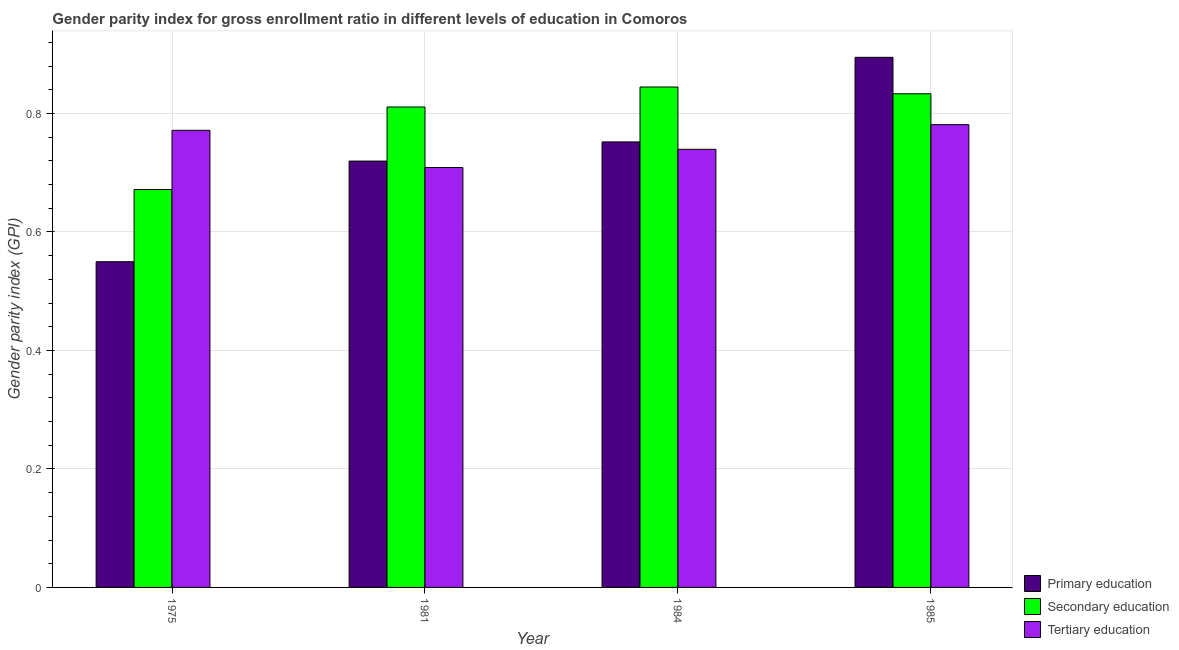How many different coloured bars are there?
Provide a succinct answer. 3. Are the number of bars per tick equal to the number of legend labels?
Your response must be concise. Yes. How many bars are there on the 2nd tick from the left?
Offer a very short reply. 3. What is the label of the 3rd group of bars from the left?
Offer a terse response. 1984. What is the gender parity index in tertiary education in 1985?
Keep it short and to the point. 0.78. Across all years, what is the maximum gender parity index in secondary education?
Offer a very short reply. 0.84. Across all years, what is the minimum gender parity index in primary education?
Provide a succinct answer. 0.55. What is the total gender parity index in tertiary education in the graph?
Your answer should be compact. 3. What is the difference between the gender parity index in secondary education in 1984 and that in 1985?
Your response must be concise. 0.01. What is the difference between the gender parity index in primary education in 1975 and the gender parity index in secondary education in 1981?
Your answer should be very brief. -0.17. What is the average gender parity index in secondary education per year?
Offer a very short reply. 0.79. In how many years, is the gender parity index in tertiary education greater than 0.4?
Your answer should be compact. 4. What is the ratio of the gender parity index in secondary education in 1975 to that in 1985?
Keep it short and to the point. 0.81. Is the gender parity index in tertiary education in 1981 less than that in 1984?
Offer a very short reply. Yes. Is the difference between the gender parity index in primary education in 1981 and 1984 greater than the difference between the gender parity index in secondary education in 1981 and 1984?
Your answer should be very brief. No. What is the difference between the highest and the second highest gender parity index in tertiary education?
Give a very brief answer. 0.01. What is the difference between the highest and the lowest gender parity index in tertiary education?
Offer a terse response. 0.07. In how many years, is the gender parity index in primary education greater than the average gender parity index in primary education taken over all years?
Your answer should be very brief. 2. Is the sum of the gender parity index in tertiary education in 1975 and 1981 greater than the maximum gender parity index in primary education across all years?
Your answer should be very brief. Yes. What does the 3rd bar from the left in 1975 represents?
Give a very brief answer. Tertiary education. Is it the case that in every year, the sum of the gender parity index in primary education and gender parity index in secondary education is greater than the gender parity index in tertiary education?
Your answer should be compact. Yes. Are all the bars in the graph horizontal?
Offer a very short reply. No. How many years are there in the graph?
Ensure brevity in your answer.  4. What is the difference between two consecutive major ticks on the Y-axis?
Offer a very short reply. 0.2. Does the graph contain any zero values?
Keep it short and to the point. No. How are the legend labels stacked?
Your response must be concise. Vertical. What is the title of the graph?
Ensure brevity in your answer.  Gender parity index for gross enrollment ratio in different levels of education in Comoros. Does "Other sectors" appear as one of the legend labels in the graph?
Your answer should be compact. No. What is the label or title of the X-axis?
Offer a very short reply. Year. What is the label or title of the Y-axis?
Ensure brevity in your answer.  Gender parity index (GPI). What is the Gender parity index (GPI) of Primary education in 1975?
Give a very brief answer. 0.55. What is the Gender parity index (GPI) of Secondary education in 1975?
Your answer should be very brief. 0.67. What is the Gender parity index (GPI) of Tertiary education in 1975?
Provide a short and direct response. 0.77. What is the Gender parity index (GPI) in Primary education in 1981?
Provide a succinct answer. 0.72. What is the Gender parity index (GPI) of Secondary education in 1981?
Ensure brevity in your answer.  0.81. What is the Gender parity index (GPI) in Tertiary education in 1981?
Make the answer very short. 0.71. What is the Gender parity index (GPI) of Primary education in 1984?
Make the answer very short. 0.75. What is the Gender parity index (GPI) of Secondary education in 1984?
Offer a terse response. 0.84. What is the Gender parity index (GPI) in Tertiary education in 1984?
Offer a terse response. 0.74. What is the Gender parity index (GPI) of Primary education in 1985?
Ensure brevity in your answer.  0.89. What is the Gender parity index (GPI) in Secondary education in 1985?
Provide a succinct answer. 0.83. What is the Gender parity index (GPI) in Tertiary education in 1985?
Make the answer very short. 0.78. Across all years, what is the maximum Gender parity index (GPI) of Primary education?
Offer a terse response. 0.89. Across all years, what is the maximum Gender parity index (GPI) in Secondary education?
Offer a terse response. 0.84. Across all years, what is the maximum Gender parity index (GPI) in Tertiary education?
Offer a terse response. 0.78. Across all years, what is the minimum Gender parity index (GPI) in Primary education?
Provide a short and direct response. 0.55. Across all years, what is the minimum Gender parity index (GPI) in Secondary education?
Provide a succinct answer. 0.67. Across all years, what is the minimum Gender parity index (GPI) of Tertiary education?
Your response must be concise. 0.71. What is the total Gender parity index (GPI) in Primary education in the graph?
Ensure brevity in your answer.  2.92. What is the total Gender parity index (GPI) in Secondary education in the graph?
Make the answer very short. 3.16. What is the total Gender parity index (GPI) of Tertiary education in the graph?
Provide a succinct answer. 3. What is the difference between the Gender parity index (GPI) of Primary education in 1975 and that in 1981?
Give a very brief answer. -0.17. What is the difference between the Gender parity index (GPI) in Secondary education in 1975 and that in 1981?
Your answer should be compact. -0.14. What is the difference between the Gender parity index (GPI) in Tertiary education in 1975 and that in 1981?
Make the answer very short. 0.06. What is the difference between the Gender parity index (GPI) in Primary education in 1975 and that in 1984?
Offer a terse response. -0.2. What is the difference between the Gender parity index (GPI) of Secondary education in 1975 and that in 1984?
Offer a terse response. -0.17. What is the difference between the Gender parity index (GPI) in Tertiary education in 1975 and that in 1984?
Your response must be concise. 0.03. What is the difference between the Gender parity index (GPI) in Primary education in 1975 and that in 1985?
Your response must be concise. -0.34. What is the difference between the Gender parity index (GPI) in Secondary education in 1975 and that in 1985?
Ensure brevity in your answer.  -0.16. What is the difference between the Gender parity index (GPI) of Tertiary education in 1975 and that in 1985?
Make the answer very short. -0.01. What is the difference between the Gender parity index (GPI) of Primary education in 1981 and that in 1984?
Your answer should be compact. -0.03. What is the difference between the Gender parity index (GPI) of Secondary education in 1981 and that in 1984?
Give a very brief answer. -0.03. What is the difference between the Gender parity index (GPI) of Tertiary education in 1981 and that in 1984?
Provide a short and direct response. -0.03. What is the difference between the Gender parity index (GPI) of Primary education in 1981 and that in 1985?
Provide a short and direct response. -0.18. What is the difference between the Gender parity index (GPI) in Secondary education in 1981 and that in 1985?
Your response must be concise. -0.02. What is the difference between the Gender parity index (GPI) in Tertiary education in 1981 and that in 1985?
Give a very brief answer. -0.07. What is the difference between the Gender parity index (GPI) in Primary education in 1984 and that in 1985?
Ensure brevity in your answer.  -0.14. What is the difference between the Gender parity index (GPI) of Secondary education in 1984 and that in 1985?
Your answer should be very brief. 0.01. What is the difference between the Gender parity index (GPI) of Tertiary education in 1984 and that in 1985?
Give a very brief answer. -0.04. What is the difference between the Gender parity index (GPI) of Primary education in 1975 and the Gender parity index (GPI) of Secondary education in 1981?
Your answer should be compact. -0.26. What is the difference between the Gender parity index (GPI) of Primary education in 1975 and the Gender parity index (GPI) of Tertiary education in 1981?
Your response must be concise. -0.16. What is the difference between the Gender parity index (GPI) in Secondary education in 1975 and the Gender parity index (GPI) in Tertiary education in 1981?
Provide a succinct answer. -0.04. What is the difference between the Gender parity index (GPI) in Primary education in 1975 and the Gender parity index (GPI) in Secondary education in 1984?
Your answer should be very brief. -0.29. What is the difference between the Gender parity index (GPI) in Primary education in 1975 and the Gender parity index (GPI) in Tertiary education in 1984?
Your response must be concise. -0.19. What is the difference between the Gender parity index (GPI) in Secondary education in 1975 and the Gender parity index (GPI) in Tertiary education in 1984?
Provide a short and direct response. -0.07. What is the difference between the Gender parity index (GPI) in Primary education in 1975 and the Gender parity index (GPI) in Secondary education in 1985?
Make the answer very short. -0.28. What is the difference between the Gender parity index (GPI) of Primary education in 1975 and the Gender parity index (GPI) of Tertiary education in 1985?
Your answer should be very brief. -0.23. What is the difference between the Gender parity index (GPI) in Secondary education in 1975 and the Gender parity index (GPI) in Tertiary education in 1985?
Provide a short and direct response. -0.11. What is the difference between the Gender parity index (GPI) of Primary education in 1981 and the Gender parity index (GPI) of Secondary education in 1984?
Provide a succinct answer. -0.12. What is the difference between the Gender parity index (GPI) in Primary education in 1981 and the Gender parity index (GPI) in Tertiary education in 1984?
Make the answer very short. -0.02. What is the difference between the Gender parity index (GPI) of Secondary education in 1981 and the Gender parity index (GPI) of Tertiary education in 1984?
Provide a short and direct response. 0.07. What is the difference between the Gender parity index (GPI) in Primary education in 1981 and the Gender parity index (GPI) in Secondary education in 1985?
Your answer should be compact. -0.11. What is the difference between the Gender parity index (GPI) in Primary education in 1981 and the Gender parity index (GPI) in Tertiary education in 1985?
Keep it short and to the point. -0.06. What is the difference between the Gender parity index (GPI) in Secondary education in 1981 and the Gender parity index (GPI) in Tertiary education in 1985?
Your answer should be compact. 0.03. What is the difference between the Gender parity index (GPI) of Primary education in 1984 and the Gender parity index (GPI) of Secondary education in 1985?
Offer a terse response. -0.08. What is the difference between the Gender parity index (GPI) of Primary education in 1984 and the Gender parity index (GPI) of Tertiary education in 1985?
Your answer should be compact. -0.03. What is the difference between the Gender parity index (GPI) in Secondary education in 1984 and the Gender parity index (GPI) in Tertiary education in 1985?
Your answer should be very brief. 0.06. What is the average Gender parity index (GPI) of Primary education per year?
Your response must be concise. 0.73. What is the average Gender parity index (GPI) of Secondary education per year?
Keep it short and to the point. 0.79. What is the average Gender parity index (GPI) in Tertiary education per year?
Ensure brevity in your answer.  0.75. In the year 1975, what is the difference between the Gender parity index (GPI) in Primary education and Gender parity index (GPI) in Secondary education?
Ensure brevity in your answer.  -0.12. In the year 1975, what is the difference between the Gender parity index (GPI) of Primary education and Gender parity index (GPI) of Tertiary education?
Keep it short and to the point. -0.22. In the year 1975, what is the difference between the Gender parity index (GPI) in Secondary education and Gender parity index (GPI) in Tertiary education?
Give a very brief answer. -0.1. In the year 1981, what is the difference between the Gender parity index (GPI) of Primary education and Gender parity index (GPI) of Secondary education?
Keep it short and to the point. -0.09. In the year 1981, what is the difference between the Gender parity index (GPI) in Primary education and Gender parity index (GPI) in Tertiary education?
Your answer should be compact. 0.01. In the year 1981, what is the difference between the Gender parity index (GPI) in Secondary education and Gender parity index (GPI) in Tertiary education?
Give a very brief answer. 0.1. In the year 1984, what is the difference between the Gender parity index (GPI) of Primary education and Gender parity index (GPI) of Secondary education?
Make the answer very short. -0.09. In the year 1984, what is the difference between the Gender parity index (GPI) of Primary education and Gender parity index (GPI) of Tertiary education?
Provide a short and direct response. 0.01. In the year 1984, what is the difference between the Gender parity index (GPI) of Secondary education and Gender parity index (GPI) of Tertiary education?
Your response must be concise. 0.11. In the year 1985, what is the difference between the Gender parity index (GPI) in Primary education and Gender parity index (GPI) in Secondary education?
Provide a succinct answer. 0.06. In the year 1985, what is the difference between the Gender parity index (GPI) of Primary education and Gender parity index (GPI) of Tertiary education?
Provide a short and direct response. 0.11. In the year 1985, what is the difference between the Gender parity index (GPI) of Secondary education and Gender parity index (GPI) of Tertiary education?
Provide a short and direct response. 0.05. What is the ratio of the Gender parity index (GPI) in Primary education in 1975 to that in 1981?
Provide a succinct answer. 0.76. What is the ratio of the Gender parity index (GPI) in Secondary education in 1975 to that in 1981?
Provide a succinct answer. 0.83. What is the ratio of the Gender parity index (GPI) in Tertiary education in 1975 to that in 1981?
Keep it short and to the point. 1.09. What is the ratio of the Gender parity index (GPI) of Primary education in 1975 to that in 1984?
Your response must be concise. 0.73. What is the ratio of the Gender parity index (GPI) of Secondary education in 1975 to that in 1984?
Ensure brevity in your answer.  0.8. What is the ratio of the Gender parity index (GPI) in Tertiary education in 1975 to that in 1984?
Your response must be concise. 1.04. What is the ratio of the Gender parity index (GPI) in Primary education in 1975 to that in 1985?
Ensure brevity in your answer.  0.61. What is the ratio of the Gender parity index (GPI) in Secondary education in 1975 to that in 1985?
Make the answer very short. 0.81. What is the ratio of the Gender parity index (GPI) in Tertiary education in 1975 to that in 1985?
Your response must be concise. 0.99. What is the ratio of the Gender parity index (GPI) of Secondary education in 1981 to that in 1984?
Make the answer very short. 0.96. What is the ratio of the Gender parity index (GPI) in Tertiary education in 1981 to that in 1984?
Provide a succinct answer. 0.96. What is the ratio of the Gender parity index (GPI) in Primary education in 1981 to that in 1985?
Give a very brief answer. 0.8. What is the ratio of the Gender parity index (GPI) in Secondary education in 1981 to that in 1985?
Provide a succinct answer. 0.97. What is the ratio of the Gender parity index (GPI) of Tertiary education in 1981 to that in 1985?
Make the answer very short. 0.91. What is the ratio of the Gender parity index (GPI) of Primary education in 1984 to that in 1985?
Provide a succinct answer. 0.84. What is the ratio of the Gender parity index (GPI) in Secondary education in 1984 to that in 1985?
Your answer should be compact. 1.01. What is the ratio of the Gender parity index (GPI) in Tertiary education in 1984 to that in 1985?
Provide a succinct answer. 0.95. What is the difference between the highest and the second highest Gender parity index (GPI) of Primary education?
Keep it short and to the point. 0.14. What is the difference between the highest and the second highest Gender parity index (GPI) of Secondary education?
Make the answer very short. 0.01. What is the difference between the highest and the second highest Gender parity index (GPI) in Tertiary education?
Your response must be concise. 0.01. What is the difference between the highest and the lowest Gender parity index (GPI) in Primary education?
Offer a very short reply. 0.34. What is the difference between the highest and the lowest Gender parity index (GPI) in Secondary education?
Ensure brevity in your answer.  0.17. What is the difference between the highest and the lowest Gender parity index (GPI) in Tertiary education?
Provide a succinct answer. 0.07. 